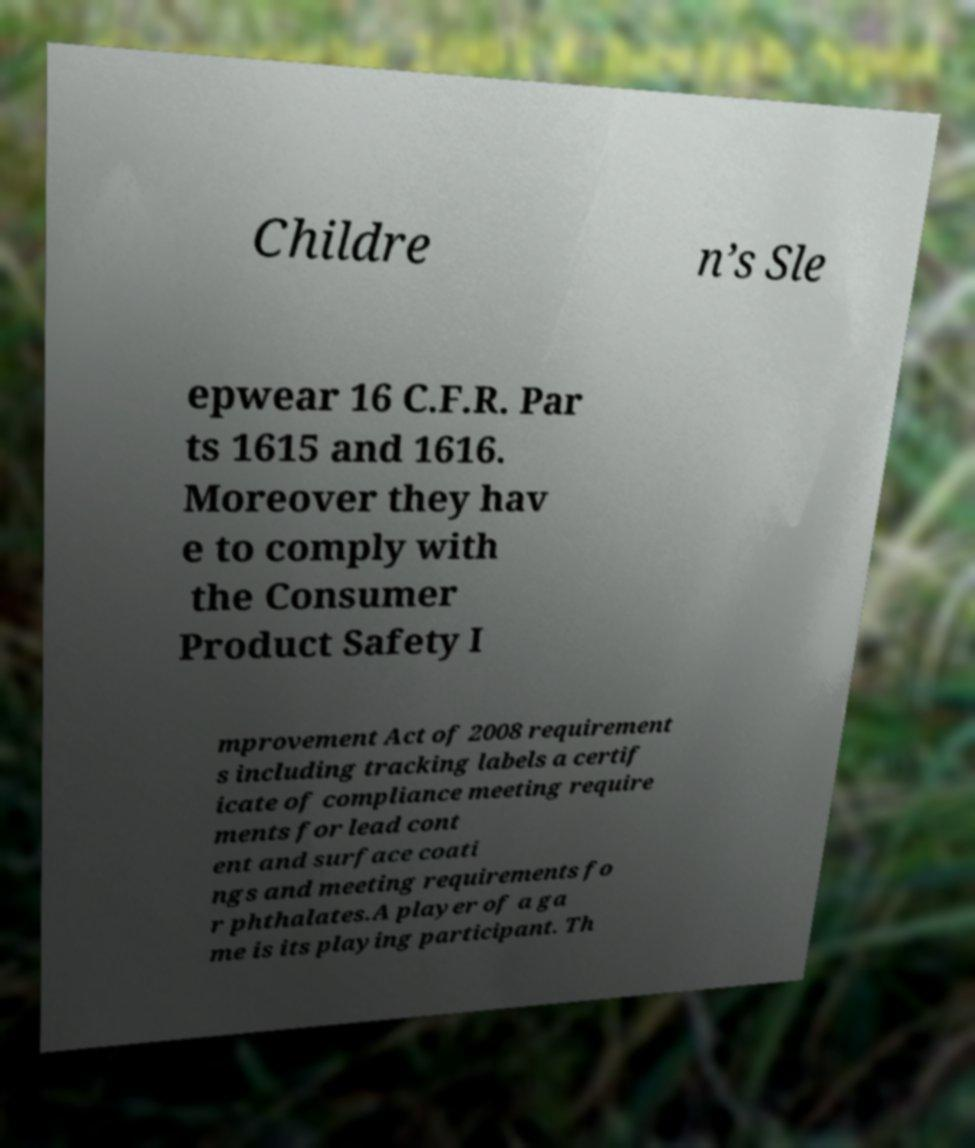For documentation purposes, I need the text within this image transcribed. Could you provide that? Childre n’s Sle epwear 16 C.F.R. Par ts 1615 and 1616. Moreover they hav e to comply with the Consumer Product Safety I mprovement Act of 2008 requirement s including tracking labels a certif icate of compliance meeting require ments for lead cont ent and surface coati ngs and meeting requirements fo r phthalates.A player of a ga me is its playing participant. Th 